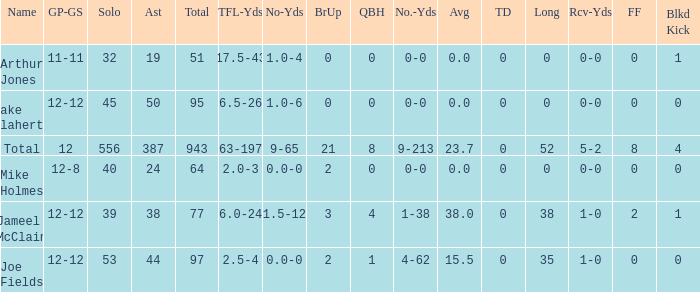How many yards for the player with tfl-yds of 2.5-4? 4-62. 